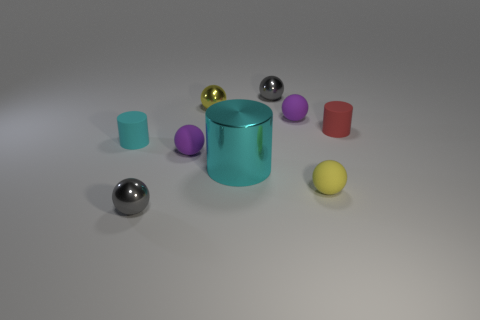Can you tell me the purpose of the collection of objects in this image? The objects appear to be a set of geometric shapes likely used for a visual demonstration or study of spatial properties and color perception. 